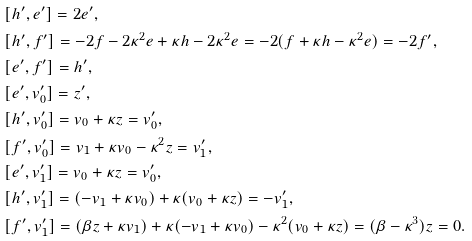<formula> <loc_0><loc_0><loc_500><loc_500>& [ h ^ { \prime } , e ^ { \prime } ] = 2 e ^ { \prime } , \\ & [ h ^ { \prime } , f ^ { \prime } ] = - 2 f - 2 \kappa ^ { 2 } e + \kappa h - 2 \kappa ^ { 2 } e = - 2 ( f + \kappa h - \kappa ^ { 2 } e ) = - 2 f ^ { \prime } , \\ & [ e ^ { \prime } , f ^ { \prime } ] = h ^ { \prime } , \\ & [ e ^ { \prime } , v _ { 0 } ^ { \prime } ] = z ^ { \prime } , \\ & [ h ^ { \prime } , v _ { 0 } ^ { \prime } ] = v _ { 0 } + \kappa z = v _ { 0 } ^ { \prime } , \\ & [ f ^ { \prime } , v _ { 0 } ^ { \prime } ] = v _ { 1 } + \kappa v _ { 0 } - \kappa ^ { 2 } z = v _ { 1 } ^ { \prime } , \\ & [ e ^ { \prime } , v _ { 1 } ^ { \prime } ] = v _ { 0 } + \kappa z = v _ { 0 } ^ { \prime } , \\ & [ h ^ { \prime } , v _ { 1 } ^ { \prime } ] = ( - v _ { 1 } + \kappa v _ { 0 } ) + \kappa ( v _ { 0 } + \kappa z ) = - v _ { 1 } ^ { \prime } , \\ & [ f ^ { \prime } , v _ { 1 } ^ { \prime } ] = ( \beta z + \kappa v _ { 1 } ) + \kappa ( - v _ { 1 } + \kappa v _ { 0 } ) - \kappa ^ { 2 } ( v _ { 0 } + \kappa z ) = ( \beta - \kappa ^ { 3 } ) z = 0 .</formula> 